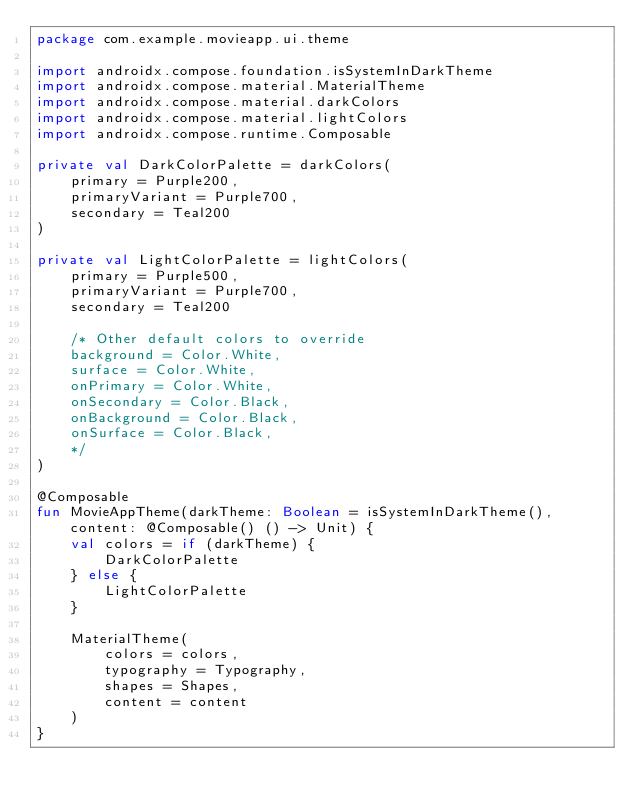<code> <loc_0><loc_0><loc_500><loc_500><_Kotlin_>package com.example.movieapp.ui.theme

import androidx.compose.foundation.isSystemInDarkTheme
import androidx.compose.material.MaterialTheme
import androidx.compose.material.darkColors
import androidx.compose.material.lightColors
import androidx.compose.runtime.Composable

private val DarkColorPalette = darkColors(
    primary = Purple200,
    primaryVariant = Purple700,
    secondary = Teal200
)

private val LightColorPalette = lightColors(
    primary = Purple500,
    primaryVariant = Purple700,
    secondary = Teal200

    /* Other default colors to override
    background = Color.White,
    surface = Color.White,
    onPrimary = Color.White,
    onSecondary = Color.Black,
    onBackground = Color.Black,
    onSurface = Color.Black,
    */
)

@Composable
fun MovieAppTheme(darkTheme: Boolean = isSystemInDarkTheme(), content: @Composable() () -> Unit) {
    val colors = if (darkTheme) {
        DarkColorPalette
    } else {
        LightColorPalette
    }

    MaterialTheme(
        colors = colors,
        typography = Typography,
        shapes = Shapes,
        content = content
    )
}</code> 